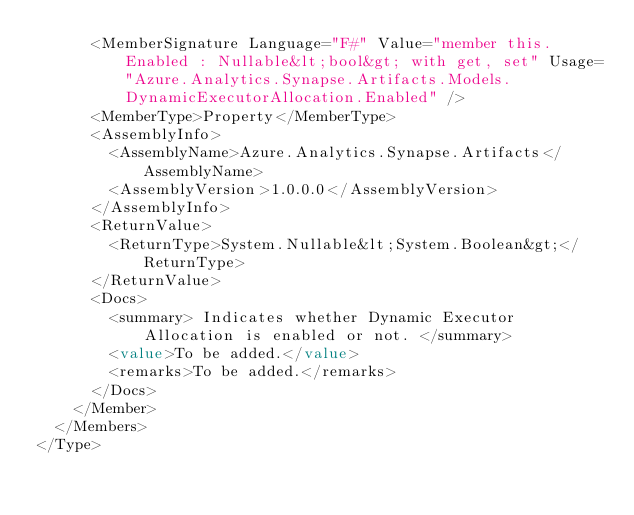<code> <loc_0><loc_0><loc_500><loc_500><_XML_>      <MemberSignature Language="F#" Value="member this.Enabled : Nullable&lt;bool&gt; with get, set" Usage="Azure.Analytics.Synapse.Artifacts.Models.DynamicExecutorAllocation.Enabled" />
      <MemberType>Property</MemberType>
      <AssemblyInfo>
        <AssemblyName>Azure.Analytics.Synapse.Artifacts</AssemblyName>
        <AssemblyVersion>1.0.0.0</AssemblyVersion>
      </AssemblyInfo>
      <ReturnValue>
        <ReturnType>System.Nullable&lt;System.Boolean&gt;</ReturnType>
      </ReturnValue>
      <Docs>
        <summary> Indicates whether Dynamic Executor Allocation is enabled or not. </summary>
        <value>To be added.</value>
        <remarks>To be added.</remarks>
      </Docs>
    </Member>
  </Members>
</Type>
</code> 